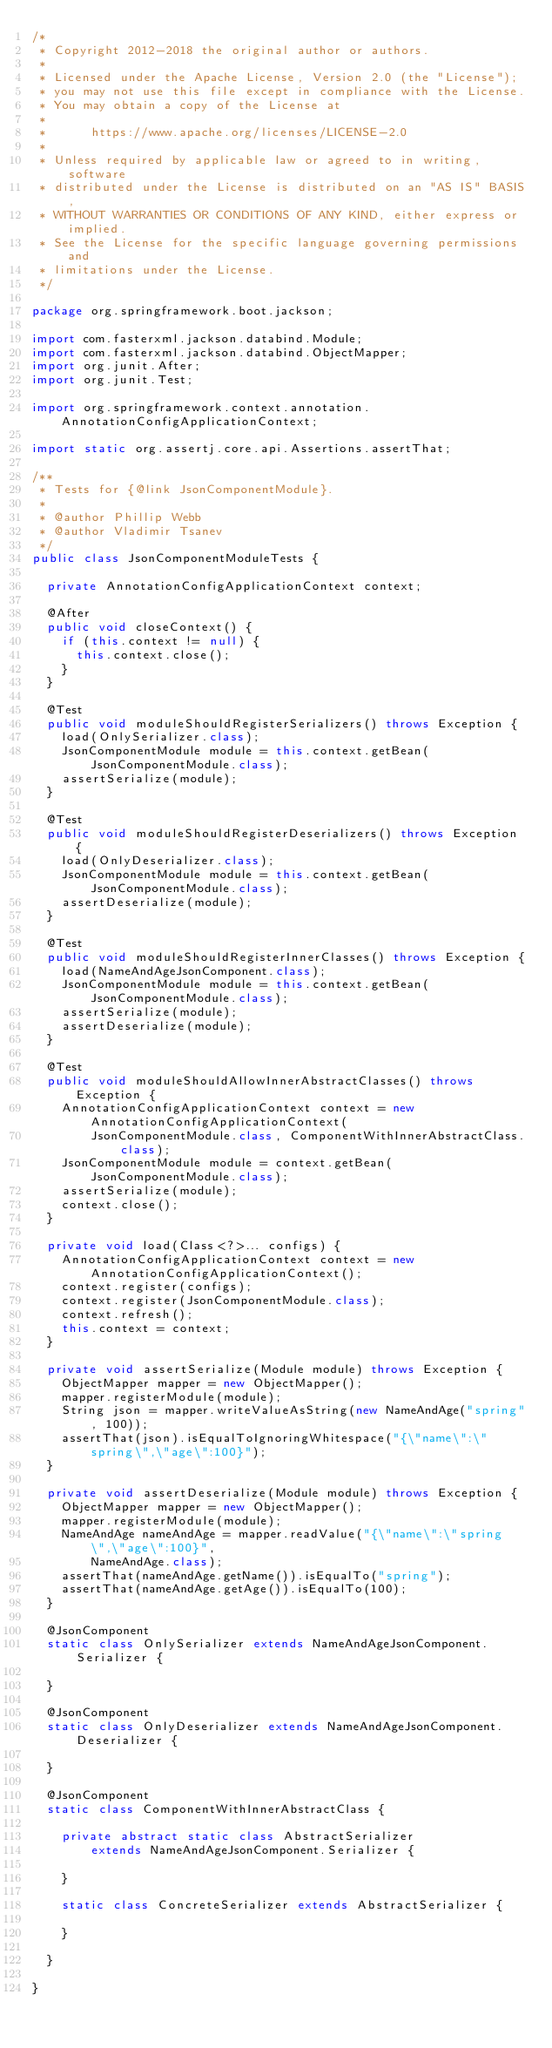Convert code to text. <code><loc_0><loc_0><loc_500><loc_500><_Java_>/*
 * Copyright 2012-2018 the original author or authors.
 *
 * Licensed under the Apache License, Version 2.0 (the "License");
 * you may not use this file except in compliance with the License.
 * You may obtain a copy of the License at
 *
 *      https://www.apache.org/licenses/LICENSE-2.0
 *
 * Unless required by applicable law or agreed to in writing, software
 * distributed under the License is distributed on an "AS IS" BASIS,
 * WITHOUT WARRANTIES OR CONDITIONS OF ANY KIND, either express or implied.
 * See the License for the specific language governing permissions and
 * limitations under the License.
 */

package org.springframework.boot.jackson;

import com.fasterxml.jackson.databind.Module;
import com.fasterxml.jackson.databind.ObjectMapper;
import org.junit.After;
import org.junit.Test;

import org.springframework.context.annotation.AnnotationConfigApplicationContext;

import static org.assertj.core.api.Assertions.assertThat;

/**
 * Tests for {@link JsonComponentModule}.
 *
 * @author Phillip Webb
 * @author Vladimir Tsanev
 */
public class JsonComponentModuleTests {

	private AnnotationConfigApplicationContext context;

	@After
	public void closeContext() {
		if (this.context != null) {
			this.context.close();
		}
	}

	@Test
	public void moduleShouldRegisterSerializers() throws Exception {
		load(OnlySerializer.class);
		JsonComponentModule module = this.context.getBean(JsonComponentModule.class);
		assertSerialize(module);
	}

	@Test
	public void moduleShouldRegisterDeserializers() throws Exception {
		load(OnlyDeserializer.class);
		JsonComponentModule module = this.context.getBean(JsonComponentModule.class);
		assertDeserialize(module);
	}

	@Test
	public void moduleShouldRegisterInnerClasses() throws Exception {
		load(NameAndAgeJsonComponent.class);
		JsonComponentModule module = this.context.getBean(JsonComponentModule.class);
		assertSerialize(module);
		assertDeserialize(module);
	}

	@Test
	public void moduleShouldAllowInnerAbstractClasses() throws Exception {
		AnnotationConfigApplicationContext context = new AnnotationConfigApplicationContext(
				JsonComponentModule.class, ComponentWithInnerAbstractClass.class);
		JsonComponentModule module = context.getBean(JsonComponentModule.class);
		assertSerialize(module);
		context.close();
	}

	private void load(Class<?>... configs) {
		AnnotationConfigApplicationContext context = new AnnotationConfigApplicationContext();
		context.register(configs);
		context.register(JsonComponentModule.class);
		context.refresh();
		this.context = context;
	}

	private void assertSerialize(Module module) throws Exception {
		ObjectMapper mapper = new ObjectMapper();
		mapper.registerModule(module);
		String json = mapper.writeValueAsString(new NameAndAge("spring", 100));
		assertThat(json).isEqualToIgnoringWhitespace("{\"name\":\"spring\",\"age\":100}");
	}

	private void assertDeserialize(Module module) throws Exception {
		ObjectMapper mapper = new ObjectMapper();
		mapper.registerModule(module);
		NameAndAge nameAndAge = mapper.readValue("{\"name\":\"spring\",\"age\":100}",
				NameAndAge.class);
		assertThat(nameAndAge.getName()).isEqualTo("spring");
		assertThat(nameAndAge.getAge()).isEqualTo(100);
	}

	@JsonComponent
	static class OnlySerializer extends NameAndAgeJsonComponent.Serializer {

	}

	@JsonComponent
	static class OnlyDeserializer extends NameAndAgeJsonComponent.Deserializer {

	}

	@JsonComponent
	static class ComponentWithInnerAbstractClass {

		private abstract static class AbstractSerializer
				extends NameAndAgeJsonComponent.Serializer {

		}

		static class ConcreteSerializer extends AbstractSerializer {

		}

	}

}
</code> 